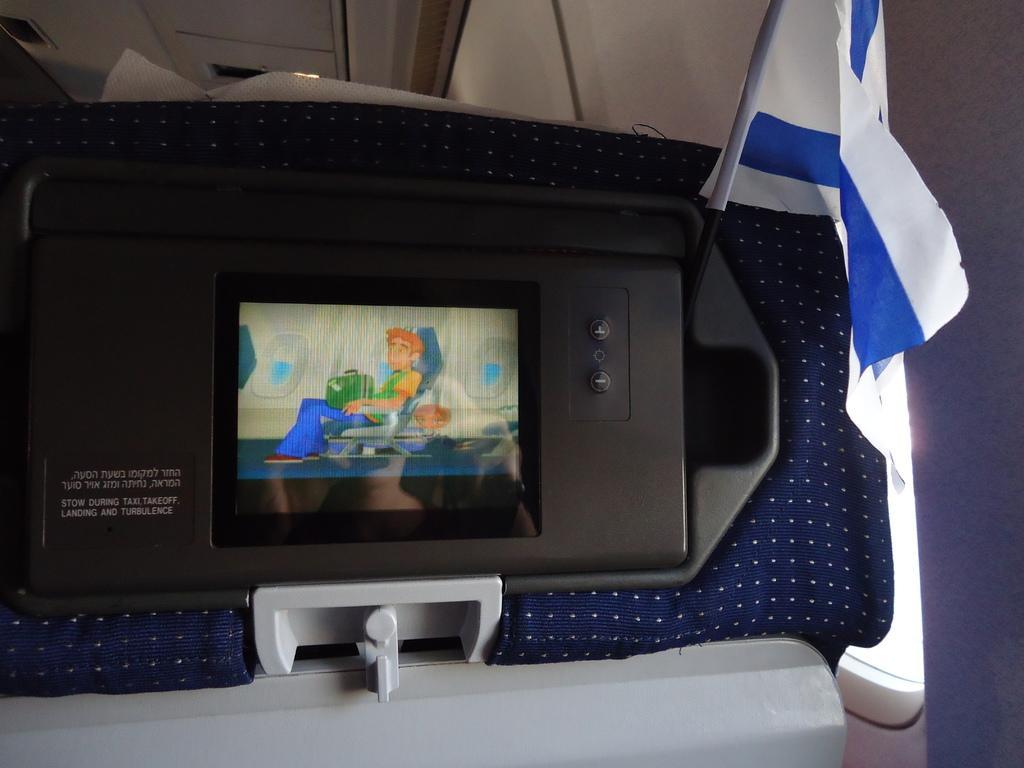How would you summarize this image in a sentence or two? In this image I can see a screen and on it I can see few cartoon characters. Here I can see something is written and I can also see a white and blue colour flag over here. 